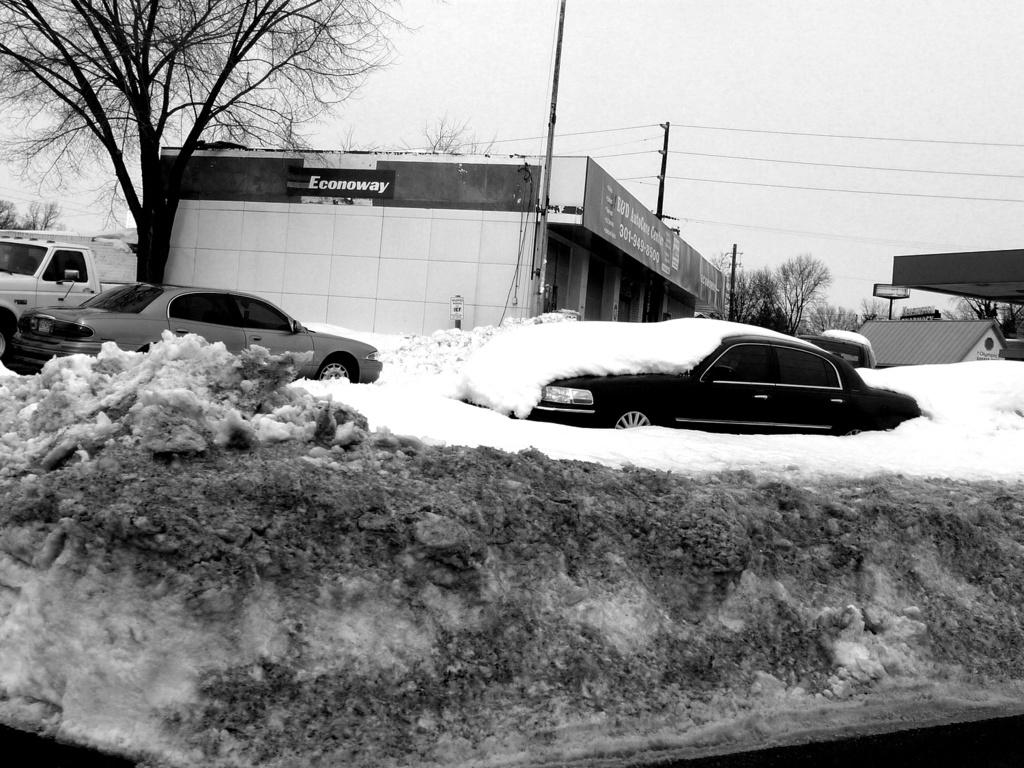What is the color scheme of the image? The image is black and white. What can be seen on the ground in the image? There are cars covered with snow in the image. What structures are visible in the background of the image? There are buildings visible in the background of the image. What type of natural elements can be seen in the background of the image? Trees are present in the background of the image. What part of the natural environment is visible in the image? The sky is visible in the image. What type of skirt is being worn by the hope in the image? There is no skirt or hope present in the image; it features cars covered with snow, buildings, trees, and the sky. 